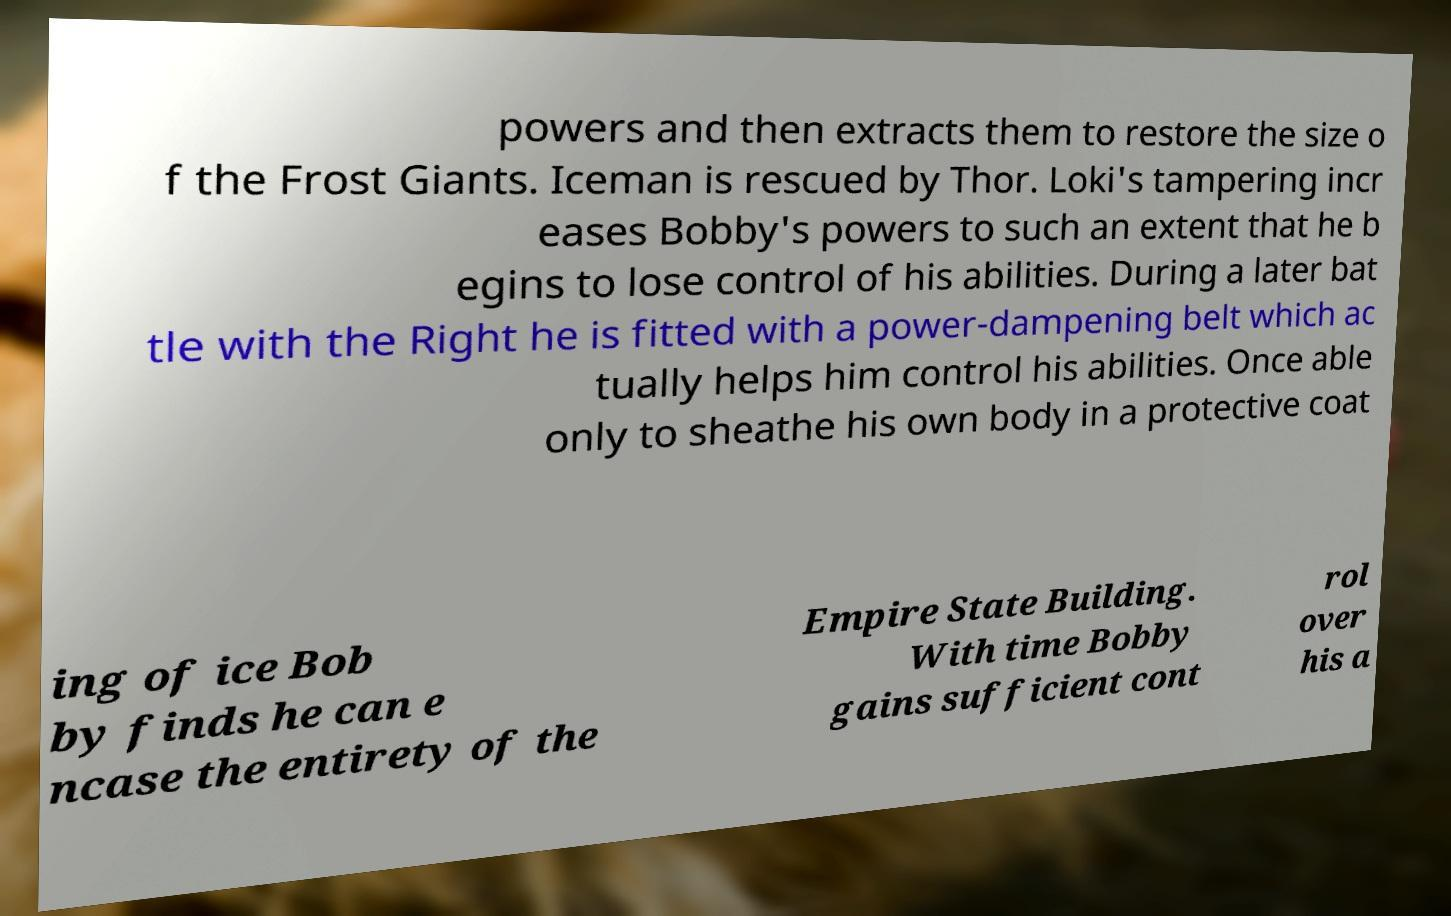For documentation purposes, I need the text within this image transcribed. Could you provide that? powers and then extracts them to restore the size o f the Frost Giants. Iceman is rescued by Thor. Loki's tampering incr eases Bobby's powers to such an extent that he b egins to lose control of his abilities. During a later bat tle with the Right he is fitted with a power-dampening belt which ac tually helps him control his abilities. Once able only to sheathe his own body in a protective coat ing of ice Bob by finds he can e ncase the entirety of the Empire State Building. With time Bobby gains sufficient cont rol over his a 